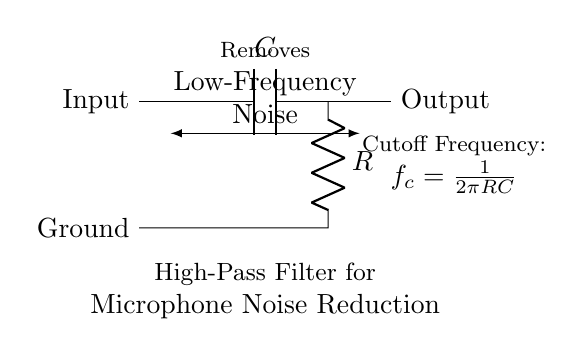What is the input of the circuit? The input of the circuit is labeled as "Input," indicating where the signal enters the high-pass filter.
Answer: Input What component is used to block low frequencies? The capacitor is the component that blocks low frequencies while allowing higher frequencies to pass, which is characteristic of high-pass filters.
Answer: Capacitor What is the output of the circuit? The output of the circuit is labeled as "Output," where the filtered signal is taken after passing through the high-pass filter components.
Answer: Output What is the role of the resistor in this circuit? The resistor works in conjunction with the capacitor to set the cutoff frequency of the filter, determining which frequencies get attenuated.
Answer: Set cutoff frequency How is the cutoff frequency calculated? The cutoff frequency is calculated using the formula f_c = 1/(2πRC), where R is the resistance and C is the capacitance in the circuit.
Answer: 1/(2πRC) What does the arrow indicate in the diagram? The arrow indicates the direction of current flow from the input to the output, establishing the path the electrical signal will take through the circuit.
Answer: Direction of current What type of filter is shown in the circuit? The circuit shown is a high-pass filter, which is used to remove low-frequency noise, particularly important in audio applications like microphones.
Answer: High-pass filter 